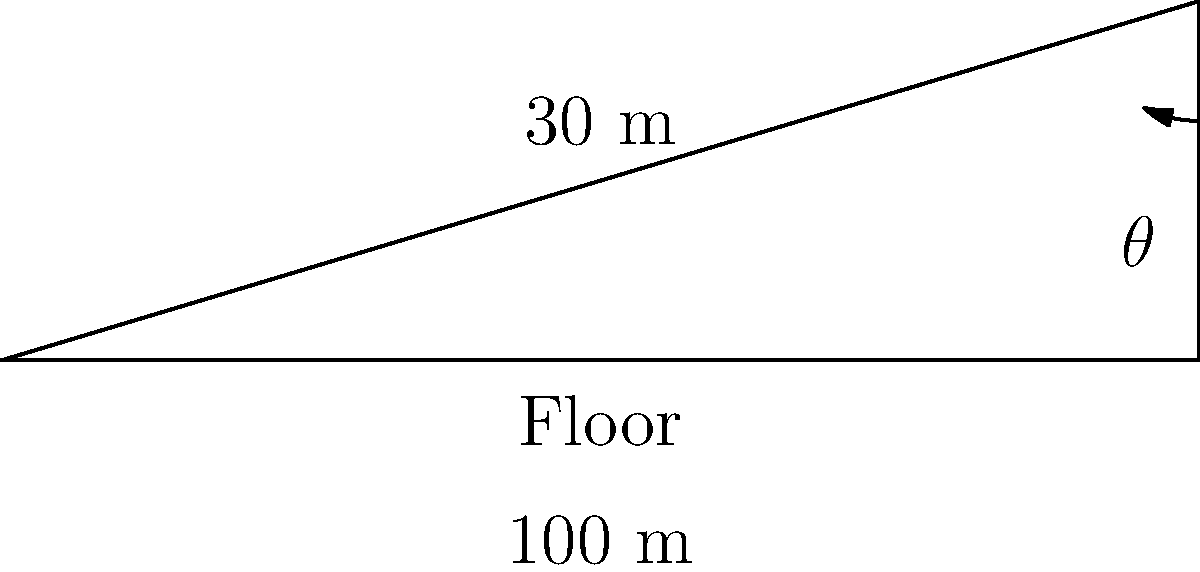At a grunge concert, the mosh pit floor is inclined to enhance crowd dynamics. If the floor rises 30 meters over a horizontal distance of 100 meters, what is the angle of inclination ($\theta$) of the mosh pit floor? To find the angle of inclination, we can use the trigonometric relationship in a right triangle:

1. The vertical rise (opposite side) is 30 meters
2. The horizontal distance (adjacent side) is 100 meters
3. We need to find the angle $\theta$

We can use the tangent function, which is defined as:

$$ \tan(\theta) = \frac{\text{opposite}}{\text{adjacent}} $$

Substituting our values:

$$ \tan(\theta) = \frac{30}{100} = 0.3 $$

To find $\theta$, we need to use the inverse tangent (arctangent) function:

$$ \theta = \tan^{-1}(0.3) $$

Using a calculator or trigonometric tables:

$$ \theta \approx 16.70^\circ $$

Rounding to the nearest degree, we get 17°.
Answer: 17° 